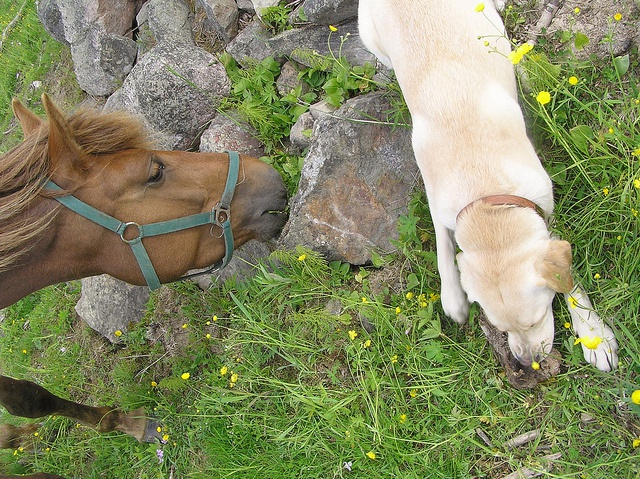Describe the objects in this image and their specific colors. I can see dog in olive, ivory, tan, and darkgray tones and horse in olive, maroon, gray, and tan tones in this image. 